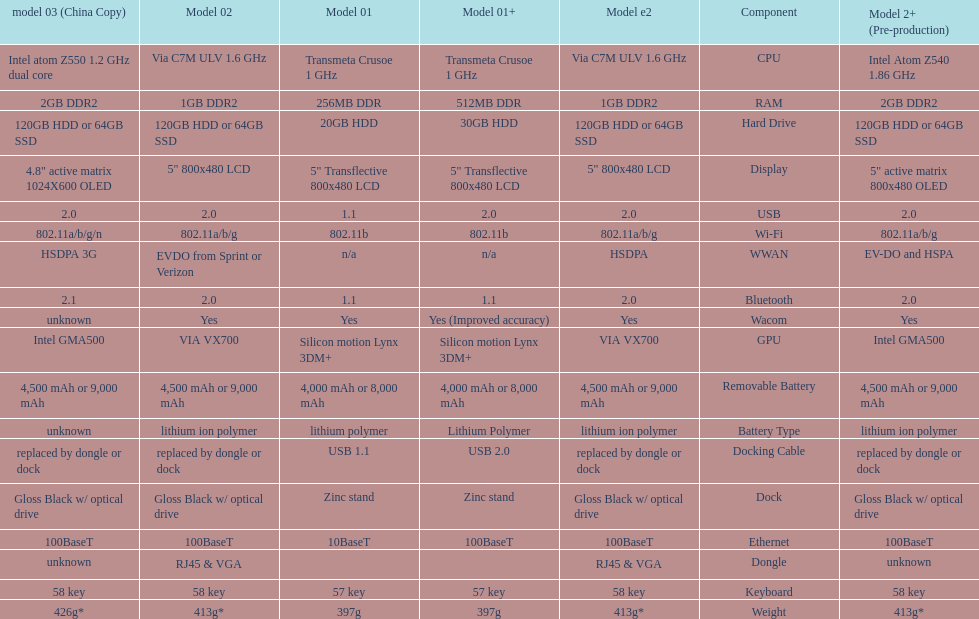How many models have 1.6ghz? 2. 